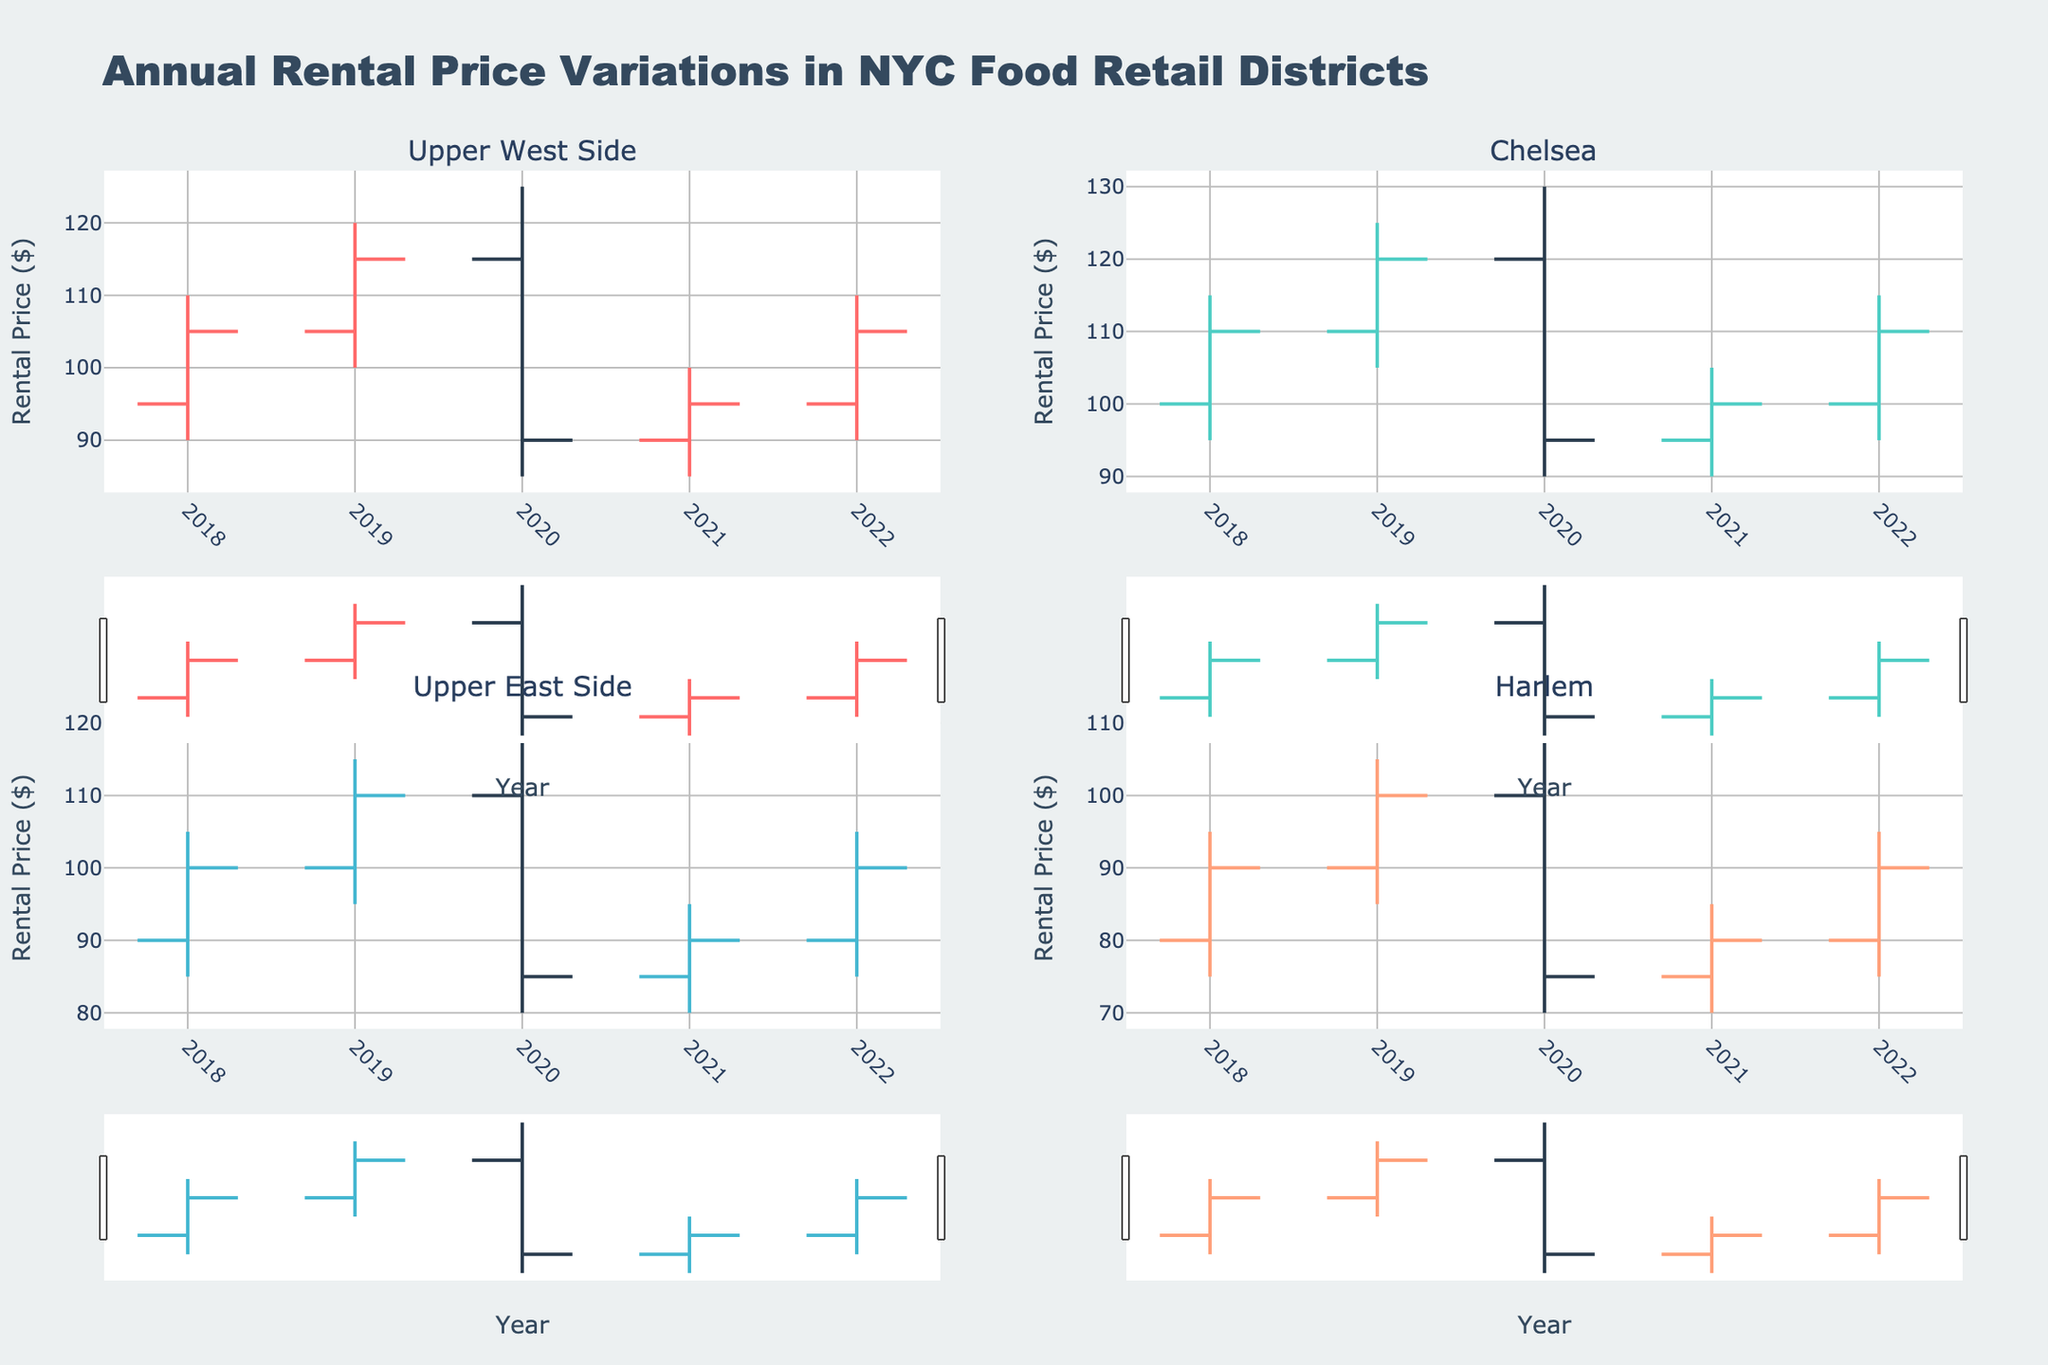When did the Upper West Side see the highest rental price peak? By looking at the OHLC chart for the Upper West Side, we observe the highest point reached by the upper shadow (high point) of the candlestick. The peak occurs in the year when the high value topped at 125.
Answer: 2020 Which district had the lowest rental price in 2020? To find the lowest price in 2020, check the 'low' points for each district's OHLC chart for that year. Harlem has the lowest value at 70.
Answer: Harlem What is the title of the figure? The title of the figure is located at the top of the chart.
Answer: Annual Rental Price Variations in NYC Food Retail Districts Compare the closing prices of Chelsea in 2018 and 2022. Which year had a higher closing price? Refer to the closing prices in the Chelsea OHLC chart for both years. The closing price for 2018 is 110, while for 2022, it is also 110. Therefore, they are equal.
Answer: Both years How much did the rental price in Harlem decrease from 2019 to 2020? Check the closing prices for Harlem in 2019 and 2020. The price decreases from 100 in 2019 to 75 in 2020. Therefore, the decrease is 100 - 75 = 25.
Answer: 25 Which district had the least variation in rental prices in 2022? To determine the least variation, check the difference between the high and low prices for all districts in 2022. Upper East Side has the least variation (105 - 85 = 20).
Answer: Upper East Side For which year did the Upper East Side record the highest opening rental price? The highest opening price is where the bottom of the box (open price) reaches the highest value in the OHLC chart for the Upper East Side. It is observed in 2020 at 110.
Answer: 2020 What color represents increasing rental prices for the Upper West Side? Refer to the color of the increasing line on the OHLC chart for the Upper West Side. The color is given as part of the visual elements. For Upper West Side, the increasing line color is one of the four distinct colors.
Answer: Red What was the maximum rental price achieved in Chelsea across the observed years? Review the 'high' values for Chelsea across all years. The maximum rental price is 130, which occurs in 2020.
Answer: 130 In 2021, how did the rental prices in the Upper East Side vary across the year? Review the OHLC chart for the Upper East Side in 2021 to find the open, high, low, and close values. In 2021, it opened at 85, went as high as 95, dropped as low as 80, and closed at 90.
Answer: Open: 85, High: 95, Low: 80, Close: 90 